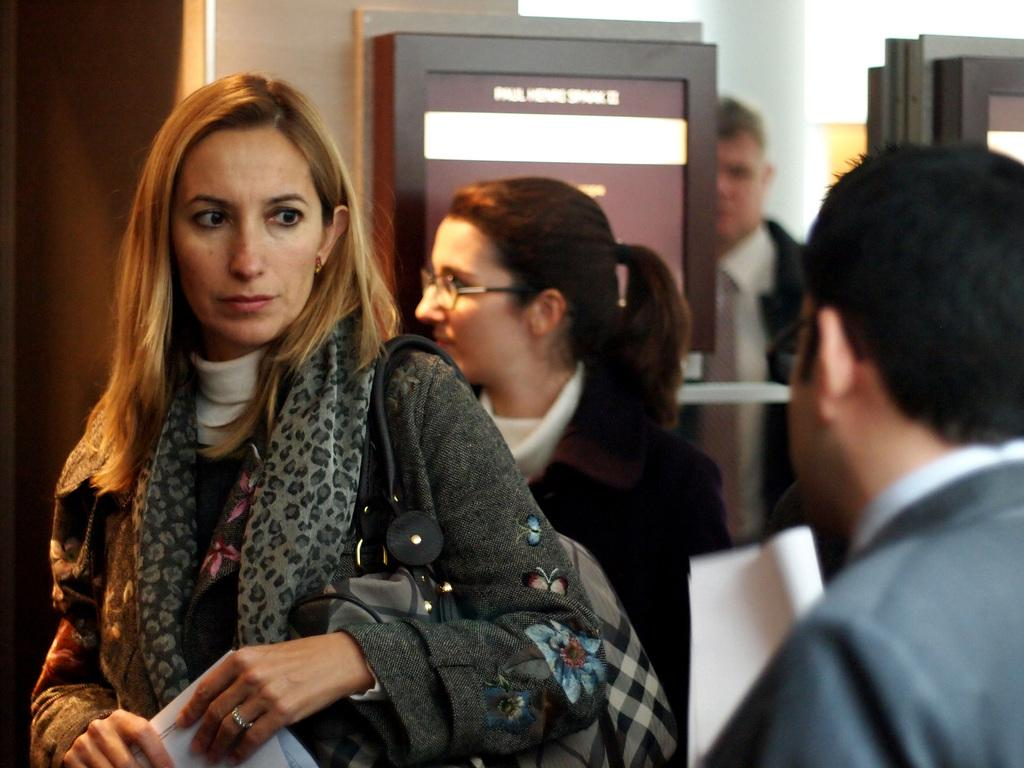What is the gender of the person in the image? There is a woman in the image. What is the woman doing in the image? The woman is standing and holding a paper. How many people are present in the image? There are three persons in the image. What objects can be seen in the image besides the people? There are boards in the image. What type of bear can be seen interacting with the woman in the image? There is no bear present in the image; it only features a woman and two other persons. What type of insurance policy is the woman discussing with the other persons in the image? There is no mention of insurance or any discussion in the image; it only shows a woman standing and holding a paper, along with two other persons and some boards. 